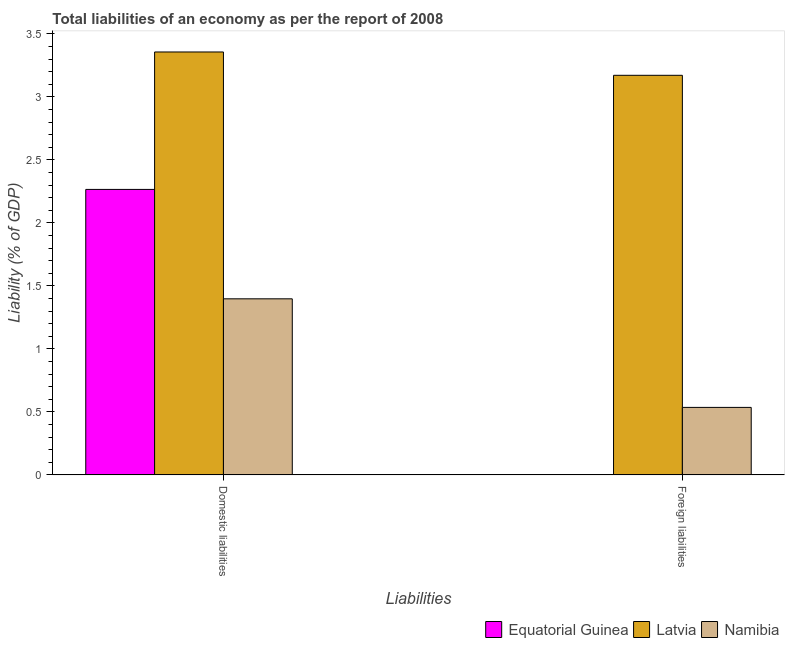Are the number of bars per tick equal to the number of legend labels?
Your answer should be very brief. No. Are the number of bars on each tick of the X-axis equal?
Offer a terse response. No. How many bars are there on the 1st tick from the right?
Give a very brief answer. 2. What is the label of the 2nd group of bars from the left?
Provide a short and direct response. Foreign liabilities. What is the incurrence of foreign liabilities in Equatorial Guinea?
Give a very brief answer. 0. Across all countries, what is the maximum incurrence of domestic liabilities?
Offer a terse response. 3.36. In which country was the incurrence of foreign liabilities maximum?
Offer a terse response. Latvia. What is the total incurrence of foreign liabilities in the graph?
Give a very brief answer. 3.71. What is the difference between the incurrence of domestic liabilities in Equatorial Guinea and that in Latvia?
Make the answer very short. -1.09. What is the difference between the incurrence of domestic liabilities in Latvia and the incurrence of foreign liabilities in Equatorial Guinea?
Offer a terse response. 3.36. What is the average incurrence of domestic liabilities per country?
Give a very brief answer. 2.34. What is the difference between the incurrence of domestic liabilities and incurrence of foreign liabilities in Namibia?
Offer a very short reply. 0.86. In how many countries, is the incurrence of foreign liabilities greater than 3.4 %?
Provide a succinct answer. 0. What is the ratio of the incurrence of foreign liabilities in Latvia to that in Namibia?
Make the answer very short. 5.92. How many bars are there?
Make the answer very short. 5. What is the difference between two consecutive major ticks on the Y-axis?
Ensure brevity in your answer.  0.5. Are the values on the major ticks of Y-axis written in scientific E-notation?
Make the answer very short. No. Where does the legend appear in the graph?
Provide a succinct answer. Bottom right. How many legend labels are there?
Give a very brief answer. 3. How are the legend labels stacked?
Provide a succinct answer. Horizontal. What is the title of the graph?
Ensure brevity in your answer.  Total liabilities of an economy as per the report of 2008. What is the label or title of the X-axis?
Ensure brevity in your answer.  Liabilities. What is the label or title of the Y-axis?
Give a very brief answer. Liability (% of GDP). What is the Liability (% of GDP) in Equatorial Guinea in Domestic liabilities?
Provide a succinct answer. 2.27. What is the Liability (% of GDP) in Latvia in Domestic liabilities?
Ensure brevity in your answer.  3.36. What is the Liability (% of GDP) in Namibia in Domestic liabilities?
Offer a very short reply. 1.4. What is the Liability (% of GDP) in Equatorial Guinea in Foreign liabilities?
Offer a terse response. 0. What is the Liability (% of GDP) of Latvia in Foreign liabilities?
Ensure brevity in your answer.  3.17. What is the Liability (% of GDP) in Namibia in Foreign liabilities?
Ensure brevity in your answer.  0.54. Across all Liabilities, what is the maximum Liability (% of GDP) in Equatorial Guinea?
Your answer should be compact. 2.27. Across all Liabilities, what is the maximum Liability (% of GDP) of Latvia?
Give a very brief answer. 3.36. Across all Liabilities, what is the maximum Liability (% of GDP) in Namibia?
Give a very brief answer. 1.4. Across all Liabilities, what is the minimum Liability (% of GDP) of Latvia?
Keep it short and to the point. 3.17. Across all Liabilities, what is the minimum Liability (% of GDP) in Namibia?
Offer a very short reply. 0.54. What is the total Liability (% of GDP) in Equatorial Guinea in the graph?
Keep it short and to the point. 2.27. What is the total Liability (% of GDP) of Latvia in the graph?
Offer a very short reply. 6.53. What is the total Liability (% of GDP) of Namibia in the graph?
Offer a very short reply. 1.93. What is the difference between the Liability (% of GDP) of Latvia in Domestic liabilities and that in Foreign liabilities?
Offer a terse response. 0.19. What is the difference between the Liability (% of GDP) of Namibia in Domestic liabilities and that in Foreign liabilities?
Give a very brief answer. 0.86. What is the difference between the Liability (% of GDP) in Equatorial Guinea in Domestic liabilities and the Liability (% of GDP) in Latvia in Foreign liabilities?
Make the answer very short. -0.91. What is the difference between the Liability (% of GDP) in Equatorial Guinea in Domestic liabilities and the Liability (% of GDP) in Namibia in Foreign liabilities?
Your response must be concise. 1.73. What is the difference between the Liability (% of GDP) in Latvia in Domestic liabilities and the Liability (% of GDP) in Namibia in Foreign liabilities?
Your answer should be compact. 2.82. What is the average Liability (% of GDP) in Equatorial Guinea per Liabilities?
Offer a very short reply. 1.13. What is the average Liability (% of GDP) in Latvia per Liabilities?
Provide a short and direct response. 3.26. What is the average Liability (% of GDP) of Namibia per Liabilities?
Ensure brevity in your answer.  0.97. What is the difference between the Liability (% of GDP) in Equatorial Guinea and Liability (% of GDP) in Latvia in Domestic liabilities?
Give a very brief answer. -1.09. What is the difference between the Liability (% of GDP) of Equatorial Guinea and Liability (% of GDP) of Namibia in Domestic liabilities?
Ensure brevity in your answer.  0.87. What is the difference between the Liability (% of GDP) of Latvia and Liability (% of GDP) of Namibia in Domestic liabilities?
Offer a very short reply. 1.96. What is the difference between the Liability (% of GDP) in Latvia and Liability (% of GDP) in Namibia in Foreign liabilities?
Give a very brief answer. 2.64. What is the ratio of the Liability (% of GDP) in Latvia in Domestic liabilities to that in Foreign liabilities?
Ensure brevity in your answer.  1.06. What is the ratio of the Liability (% of GDP) of Namibia in Domestic liabilities to that in Foreign liabilities?
Make the answer very short. 2.61. What is the difference between the highest and the second highest Liability (% of GDP) in Latvia?
Provide a succinct answer. 0.19. What is the difference between the highest and the second highest Liability (% of GDP) of Namibia?
Keep it short and to the point. 0.86. What is the difference between the highest and the lowest Liability (% of GDP) in Equatorial Guinea?
Make the answer very short. 2.27. What is the difference between the highest and the lowest Liability (% of GDP) of Latvia?
Your response must be concise. 0.19. What is the difference between the highest and the lowest Liability (% of GDP) in Namibia?
Provide a short and direct response. 0.86. 